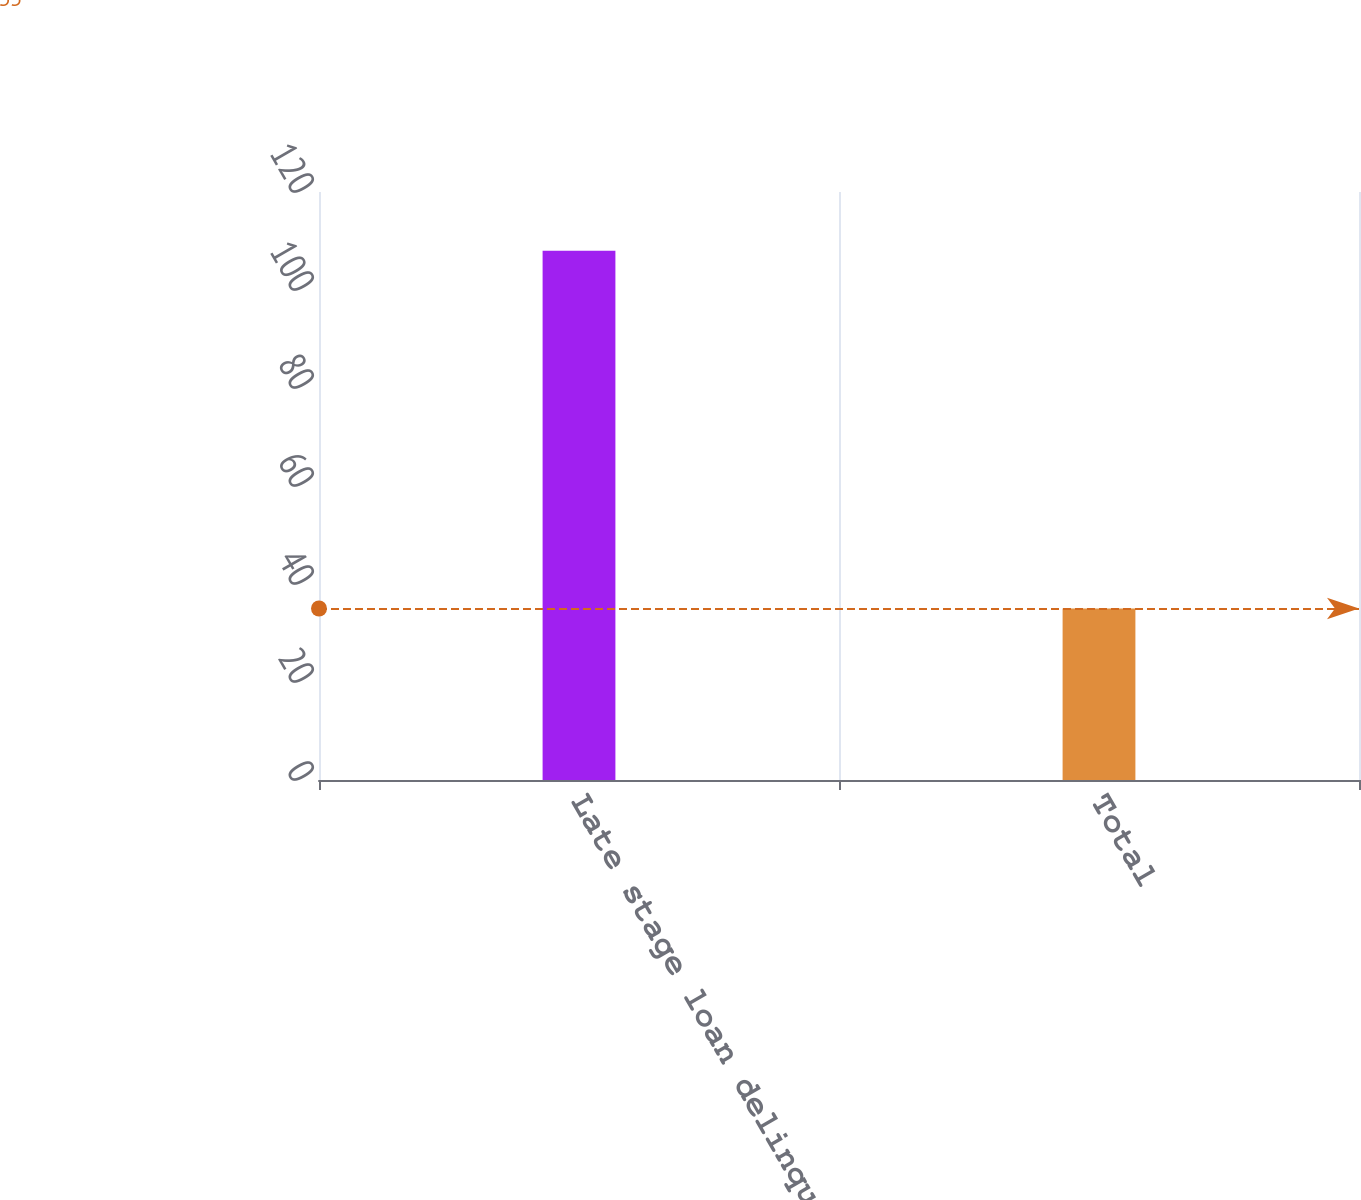Convert chart to OTSL. <chart><loc_0><loc_0><loc_500><loc_500><bar_chart><fcel>Late stage loan delinquencies<fcel>Total<nl><fcel>108<fcel>35<nl></chart> 